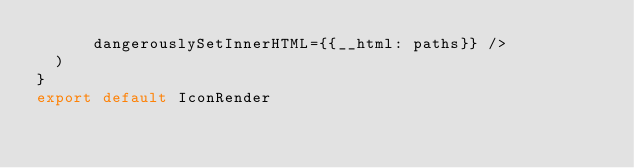Convert code to text. <code><loc_0><loc_0><loc_500><loc_500><_JavaScript_>      dangerouslySetInnerHTML={{__html: paths}} />
  )
}
export default IconRender</code> 